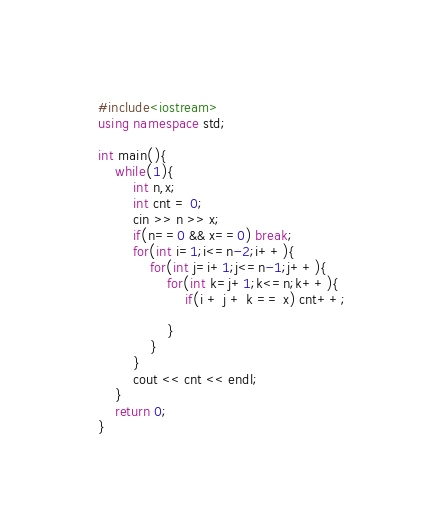<code> <loc_0><loc_0><loc_500><loc_500><_C++_>#include<iostream>
using namespace std;

int main(){
    while(1){
        int n,x;
        int cnt = 0;
        cin >> n >> x;
        if(n==0 && x==0) break;
        for(int i=1;i<=n-2;i++){
            for(int j=i+1;j<=n-1;j++){
                for(int k=j+1;k<=n;k++){
                    if(i + j + k == x) cnt++;
                
                }
            }
        }
        cout << cnt << endl;
    }
    return 0;
}
</code> 